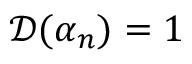<formula> <loc_0><loc_0><loc_500><loc_500>\mathcal { D } ( \alpha _ { n } ) = 1</formula> 